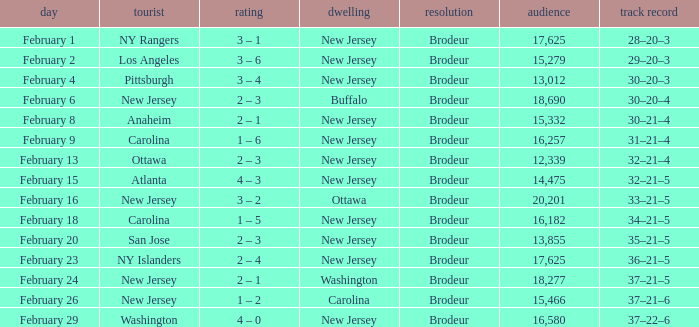What was the score when the NY Islanders was the visiting team? 2 – 4. 